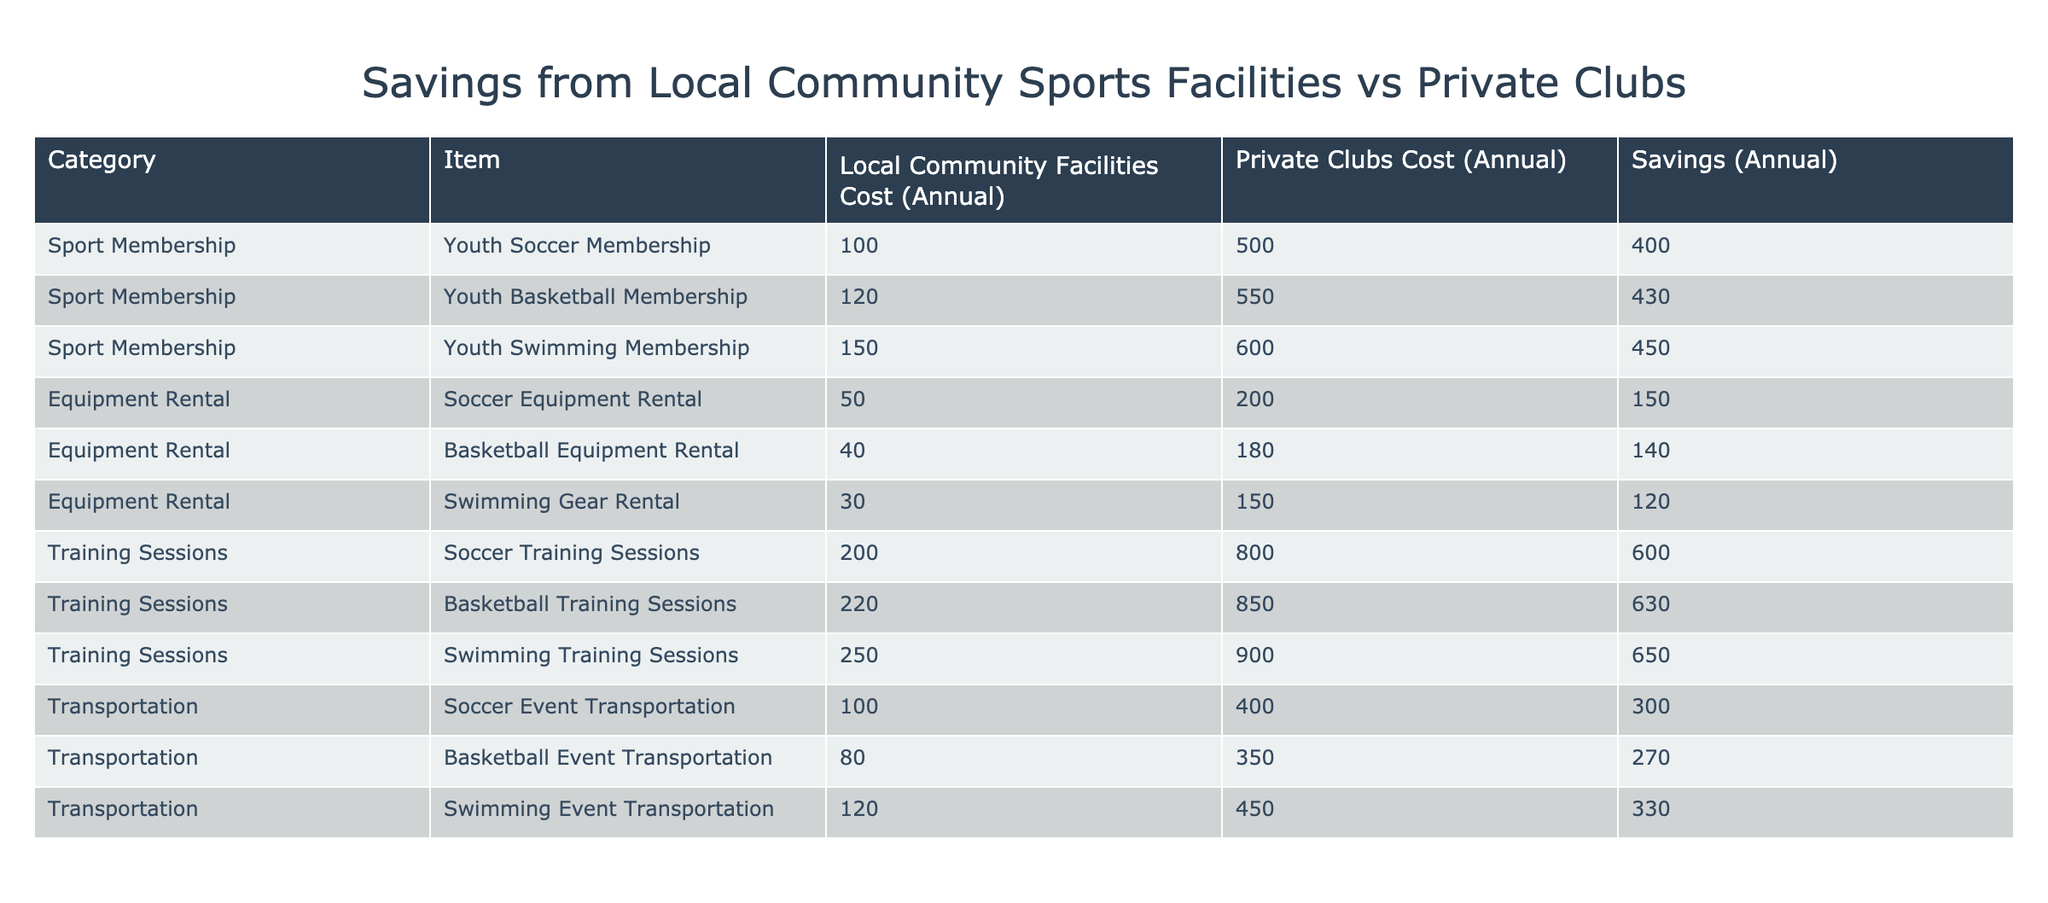What is the savings for Youth Soccer Membership? The Youth Soccer Membership's cost for local community facilities is 100, while for private clubs it is 500. Therefore, the savings is calculated as 500 - 100 = 400.
Answer: 400 What is the total savings achieved from using local community facilities in Equipment Rental? The savings from Equipment Rental are as follows: Soccer Equipment Rental has savings of 150, Basketball Equipment Rental has 140, and Swimming Gear Rental has 120. Adding these together gives 150 + 140 + 120 = 410.
Answer: 410 Is the savings for Youth Swimming Membership greater than 400? The savings for Youth Swimming Membership is listed as 450, which is indeed greater than 400.
Answer: Yes What is the highest savings among the Training Sessions? The savings for the Training Sessions are: Soccer Training Sessions has 600, Basketball Training Sessions has 630, and Swimming Training Sessions has 650. The highest saving is from Swimming Training Sessions, which is 650.
Answer: 650 What is the average savings for the Transportation category? The savings for Transportation are: Soccer Event Transportation 300, Basketball Event Transportation 270, and Swimming Event Transportation 330. To calculate the average, we sum these savings: 300 + 270 + 330 = 900, and then divide by the number of categories (3), giving us 900 / 3 = 300.
Answer: 300 Is it true that all sport memberships save more than 400 dollars? Youth Soccer Membership saves 400 dollars, Youth Basketball Membership saves 430 dollars, and Youth Swimming Membership saves 450 dollars. Since Youth Soccer Membership is exactly 400 (not more), the statement is false.
Answer: No What is the total savings for all categories in the table? The savings for each category are: Sport Membership 400 + 430 + 450 = 1280, Equipment Rental 150 + 140 + 120 = 410, Training Sessions 600 + 630 + 650 = 1880, and Transportation 300 + 270 + 330 = 900. Summing these gives 1280 + 410 + 1880 + 900 = 4460.
Answer: 4460 What is the savings for Basketball Training Sessions compared to Soccer Training Sessions? The savings for Basketball Training Sessions is 630 and for Soccer Training Sessions is 600. To find the difference, we subtract 600 from 630, which gives us 630 - 600 = 30.
Answer: 30 Are the rental costs for Soccer Equipment at community facilities lower than 100? The cost for Soccer Equipment Rental at local community facilities is 50, which is lower than 100.
Answer: Yes 